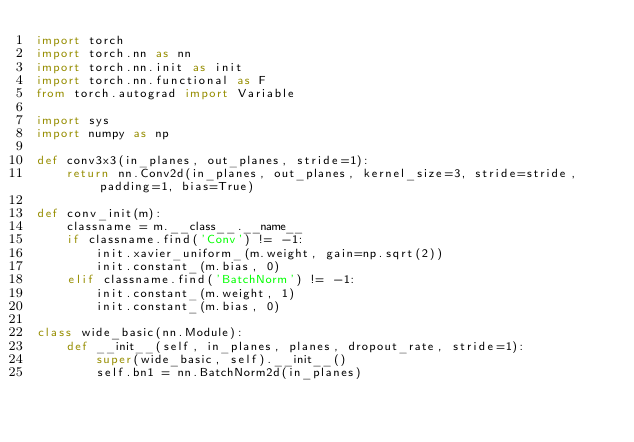Convert code to text. <code><loc_0><loc_0><loc_500><loc_500><_Python_>import torch
import torch.nn as nn
import torch.nn.init as init
import torch.nn.functional as F
from torch.autograd import Variable

import sys
import numpy as np

def conv3x3(in_planes, out_planes, stride=1):
    return nn.Conv2d(in_planes, out_planes, kernel_size=3, stride=stride, padding=1, bias=True)

def conv_init(m):
    classname = m.__class__.__name__
    if classname.find('Conv') != -1:
        init.xavier_uniform_(m.weight, gain=np.sqrt(2))
        init.constant_(m.bias, 0)
    elif classname.find('BatchNorm') != -1:
        init.constant_(m.weight, 1)
        init.constant_(m.bias, 0)

class wide_basic(nn.Module):
    def __init__(self, in_planes, planes, dropout_rate, stride=1):
        super(wide_basic, self).__init__()
        self.bn1 = nn.BatchNorm2d(in_planes)</code> 